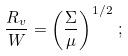Convert formula to latex. <formula><loc_0><loc_0><loc_500><loc_500>\frac { R _ { v } } { W } = \left ( \frac { \Sigma } { \mu } \right ) ^ { 1 / 2 } \, ;</formula> 